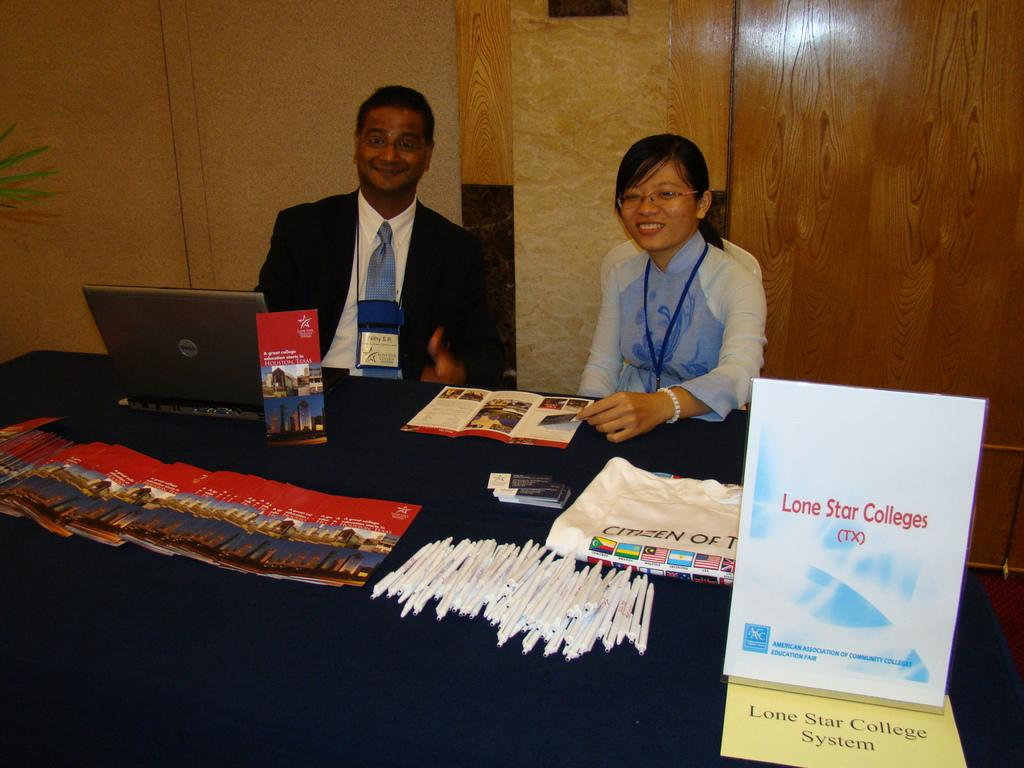<image>
Share a concise interpretation of the image provided. A promotion table with representatives and information for Lone Star colleges. 